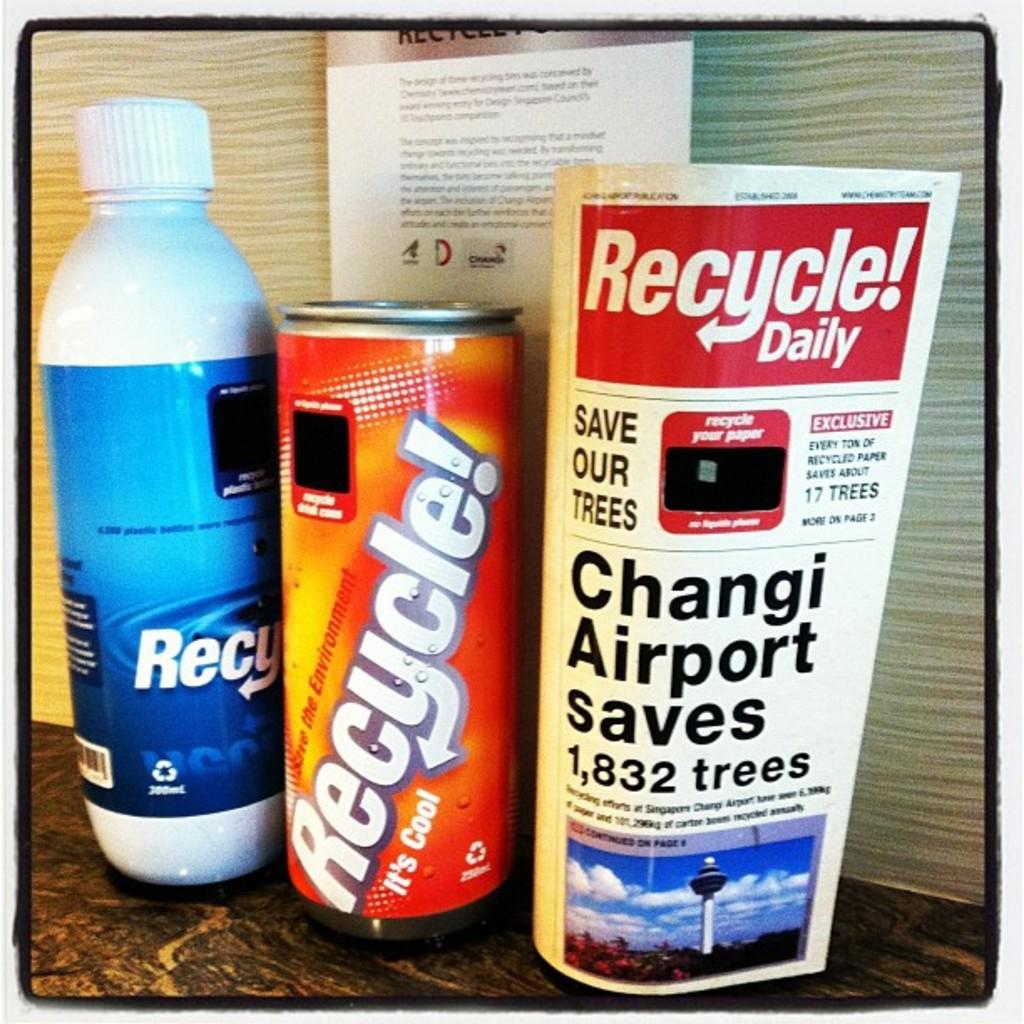What is the name of the bottle to the left?
Give a very brief answer. Recycle. 